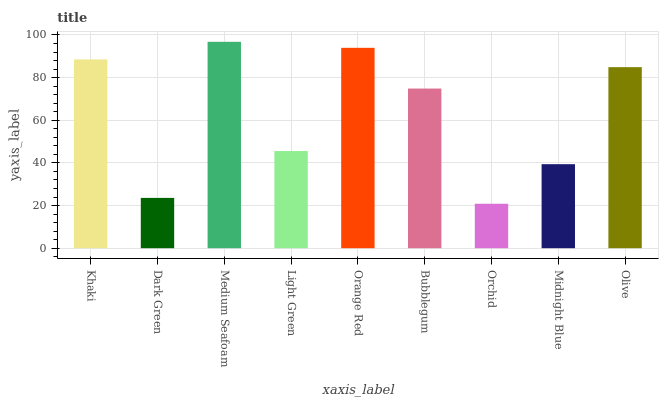Is Dark Green the minimum?
Answer yes or no. No. Is Dark Green the maximum?
Answer yes or no. No. Is Khaki greater than Dark Green?
Answer yes or no. Yes. Is Dark Green less than Khaki?
Answer yes or no. Yes. Is Dark Green greater than Khaki?
Answer yes or no. No. Is Khaki less than Dark Green?
Answer yes or no. No. Is Bubblegum the high median?
Answer yes or no. Yes. Is Bubblegum the low median?
Answer yes or no. Yes. Is Orchid the high median?
Answer yes or no. No. Is Orchid the low median?
Answer yes or no. No. 